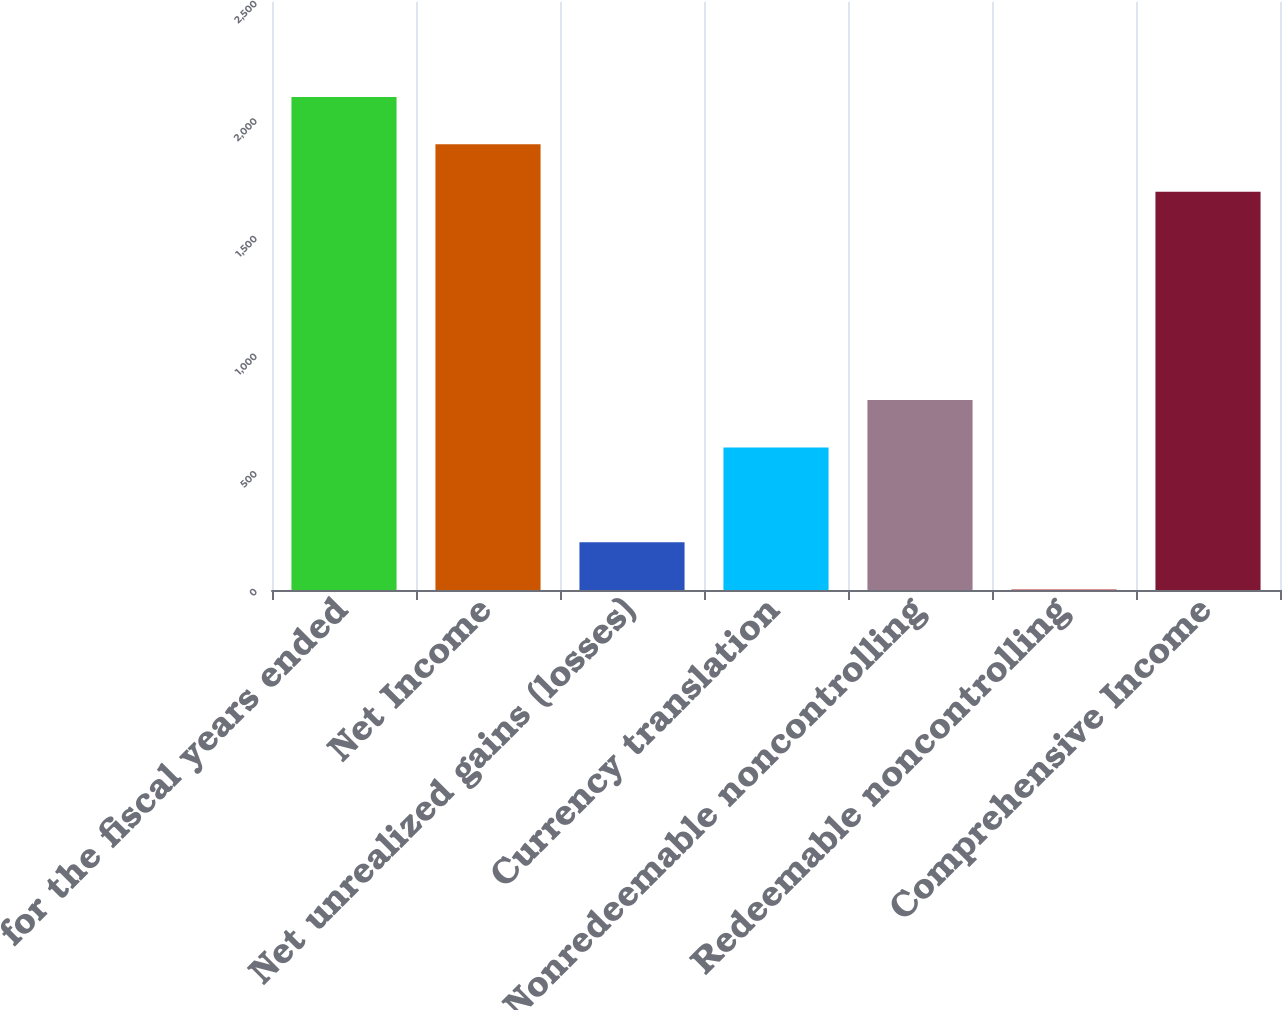<chart> <loc_0><loc_0><loc_500><loc_500><bar_chart><fcel>for the fiscal years ended<fcel>Net Income<fcel>Net unrealized gains (losses)<fcel>Currency translation<fcel>Nonredeemable noncontrolling<fcel>Redeemable noncontrolling<fcel>Comprehensive Income<nl><fcel>2096.38<fcel>1894.94<fcel>203.04<fcel>605.92<fcel>807.36<fcel>1.6<fcel>1693.5<nl></chart> 